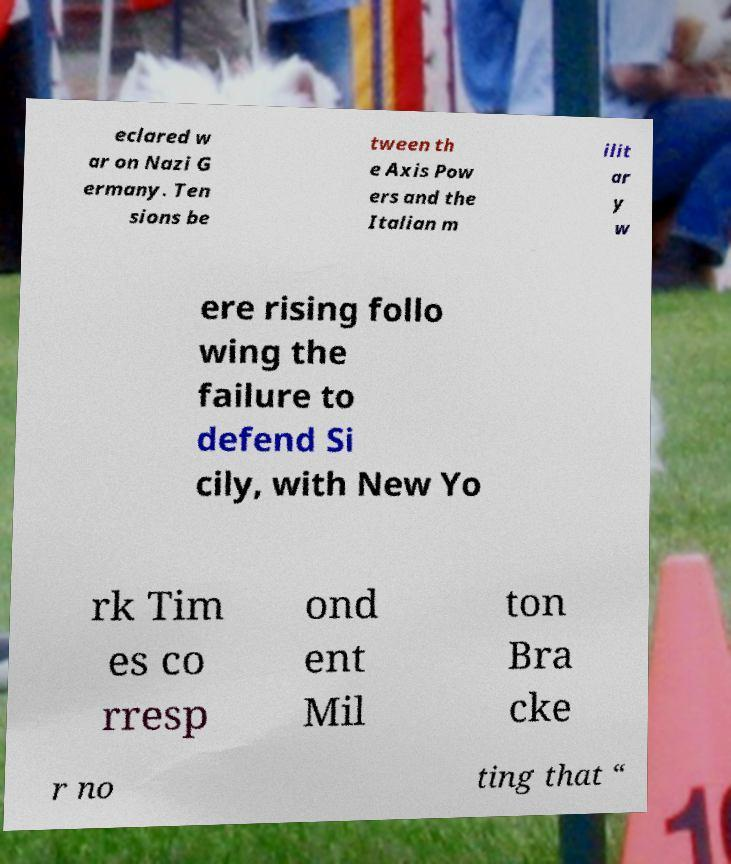Can you read and provide the text displayed in the image?This photo seems to have some interesting text. Can you extract and type it out for me? eclared w ar on Nazi G ermany. Ten sions be tween th e Axis Pow ers and the Italian m ilit ar y w ere rising follo wing the failure to defend Si cily, with New Yo rk Tim es co rresp ond ent Mil ton Bra cke r no ting that “ 